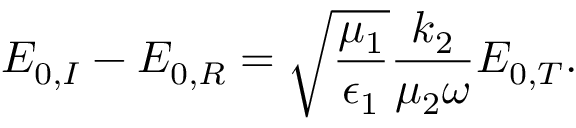Convert formula to latex. <formula><loc_0><loc_0><loc_500><loc_500>E _ { 0 , I } - E _ { 0 , R } = \sqrt { \frac { \mu _ { 1 } } { \epsilon _ { 1 } } } \frac { k _ { 2 } } { \mu _ { 2 } \omega } E _ { 0 , T } .</formula> 